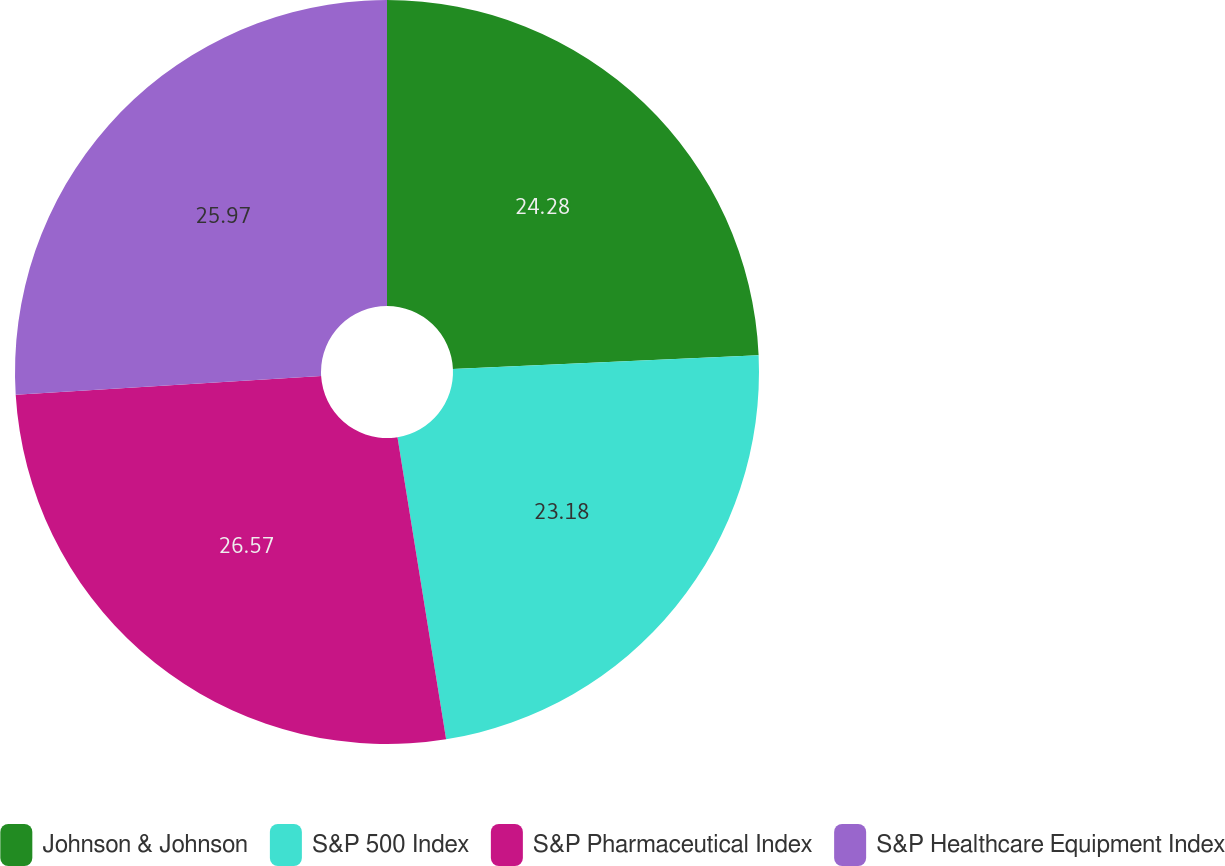Convert chart. <chart><loc_0><loc_0><loc_500><loc_500><pie_chart><fcel>Johnson & Johnson<fcel>S&P 500 Index<fcel>S&P Pharmaceutical Index<fcel>S&P Healthcare Equipment Index<nl><fcel>24.28%<fcel>23.18%<fcel>26.57%<fcel>25.97%<nl></chart> 